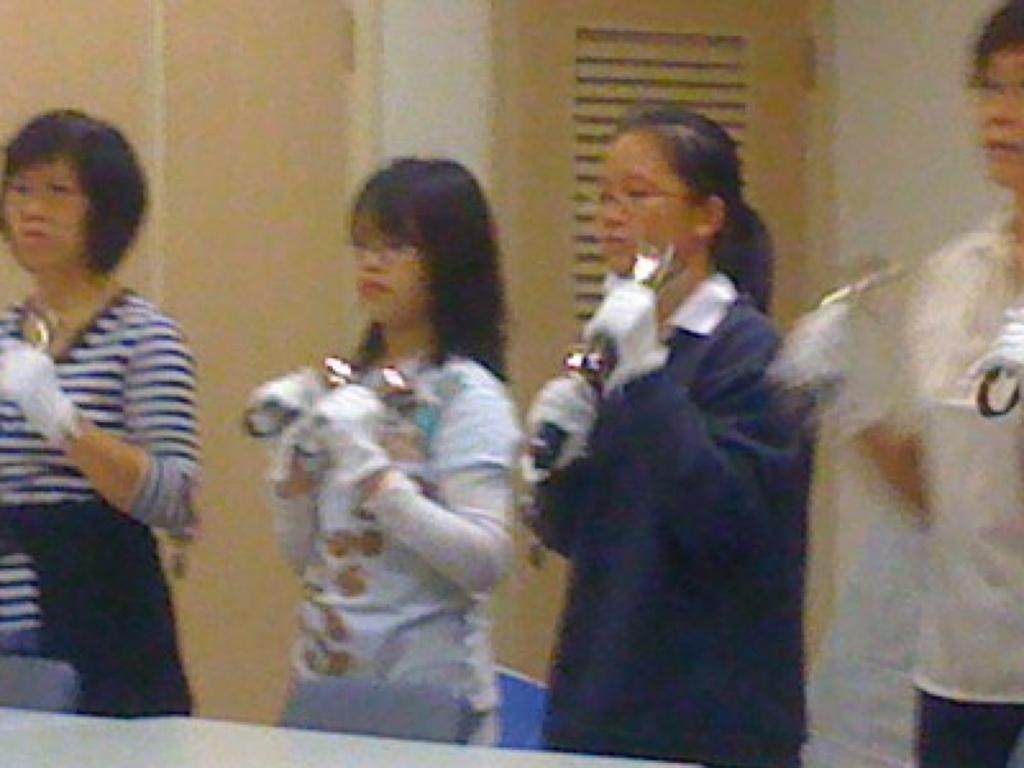What can be seen in the image? There are people standing in the image, holding objects in their hands. What type of furniture is present in the image? There are chairs and a table in the image. What can be seen in the background of the image? There is a wall and a door in the background of the image. What sign is displayed on the wall in the image? There is no sign displayed on the wall in the image. What time of day is it in the image? The time of day cannot be determined from the image. 